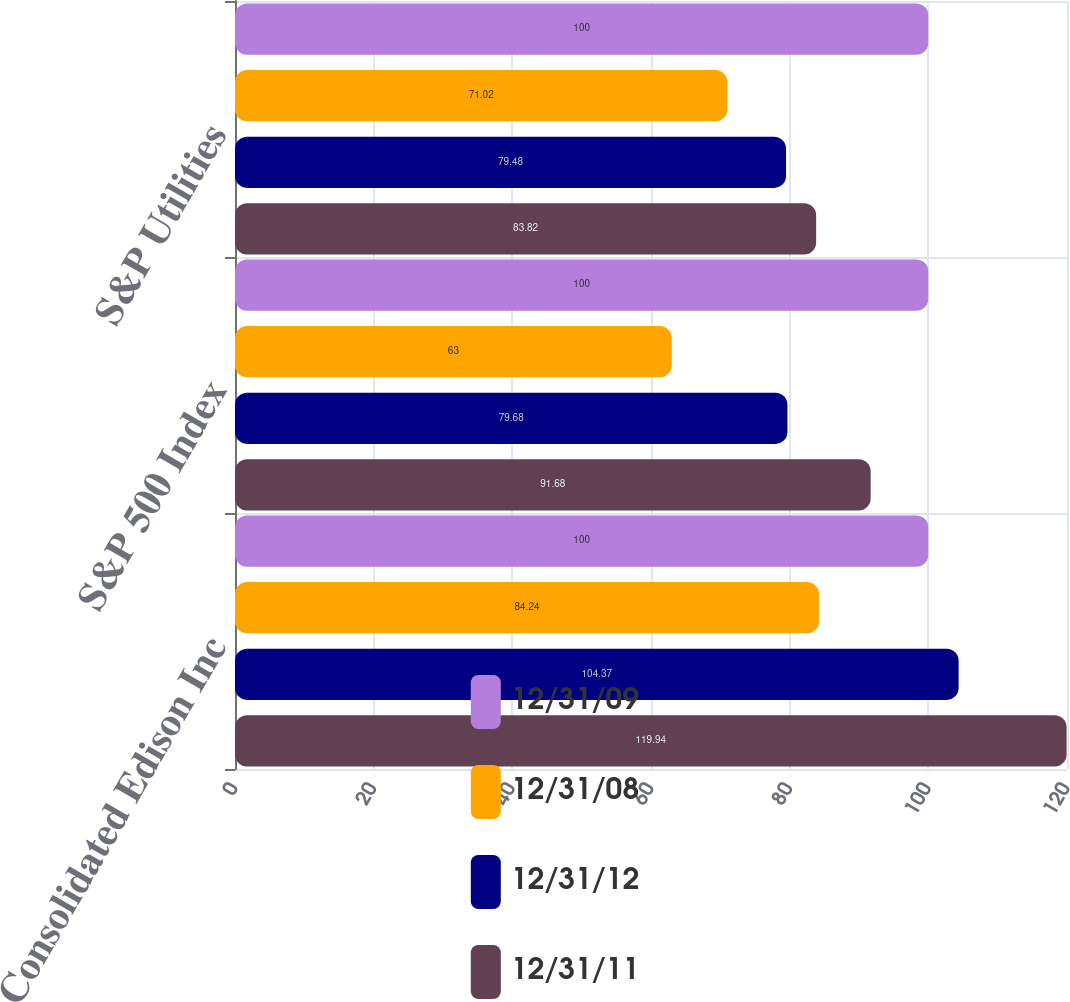Convert chart to OTSL. <chart><loc_0><loc_0><loc_500><loc_500><stacked_bar_chart><ecel><fcel>Consolidated Edison Inc<fcel>S&P 500 Index<fcel>S&P Utilities<nl><fcel>12/31/09<fcel>100<fcel>100<fcel>100<nl><fcel>12/31/08<fcel>84.24<fcel>63<fcel>71.02<nl><fcel>12/31/12<fcel>104.37<fcel>79.68<fcel>79.48<nl><fcel>12/31/11<fcel>119.94<fcel>91.68<fcel>83.82<nl></chart> 